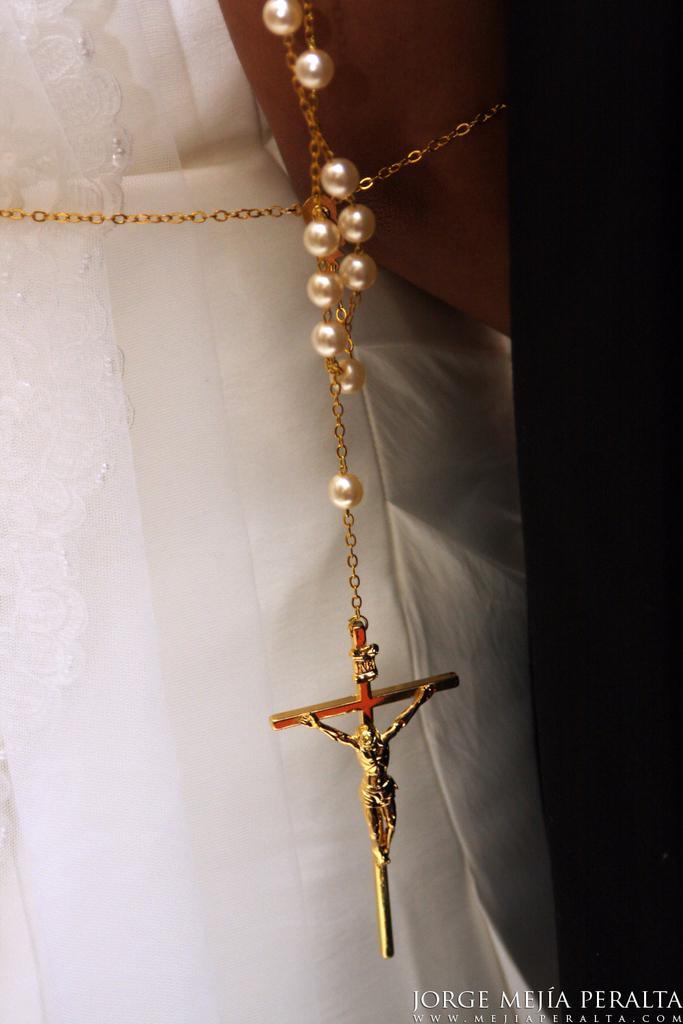Can you describe this image briefly? In this image I can see the person wearing the white color dress and I can see the chain which is in gold color. 